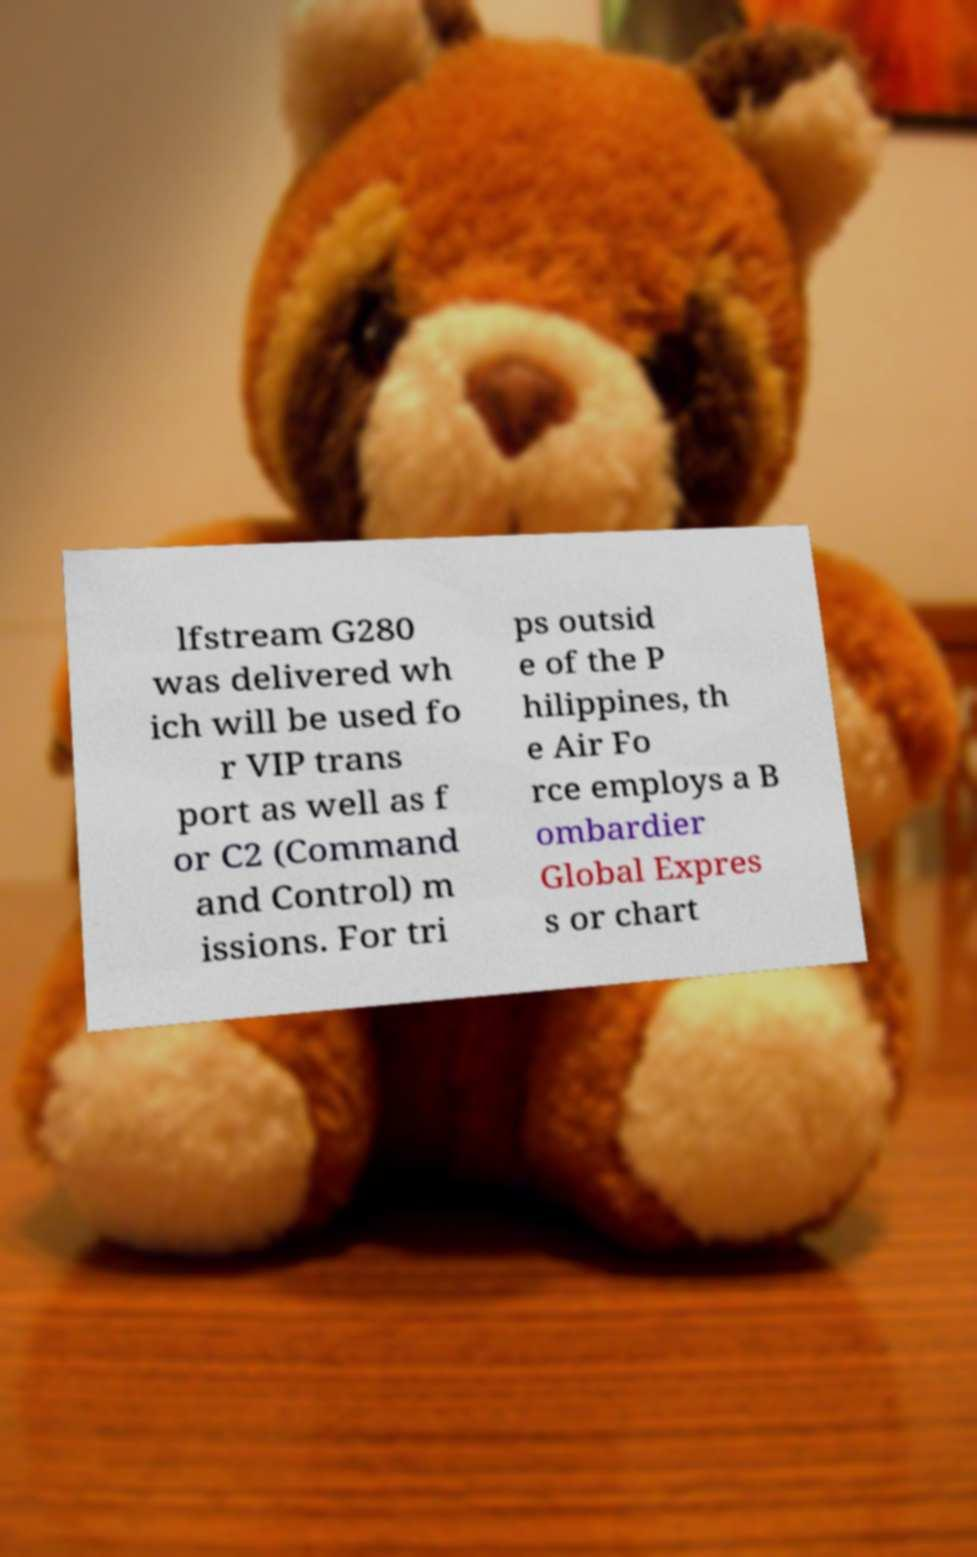Can you accurately transcribe the text from the provided image for me? lfstream G280 was delivered wh ich will be used fo r VIP trans port as well as f or C2 (Command and Control) m issions. For tri ps outsid e of the P hilippines, th e Air Fo rce employs a B ombardier Global Expres s or chart 